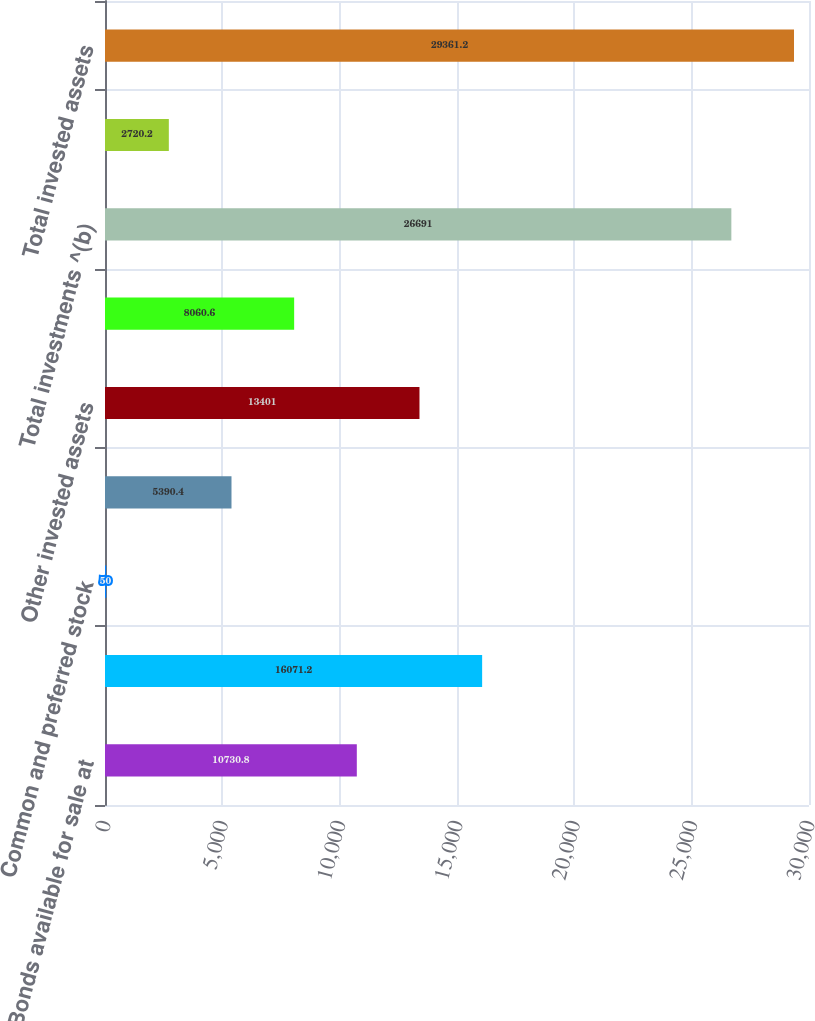Convert chart to OTSL. <chart><loc_0><loc_0><loc_500><loc_500><bar_chart><fcel>Bonds available for sale at<fcel>Other bond securities at fair<fcel>Common and preferred stock<fcel>Mortgage and other loans<fcel>Other invested assets<fcel>Short-term investments<fcel>Total investments ^(b)<fcel>Cash<fcel>Total invested assets<nl><fcel>10730.8<fcel>16071.2<fcel>50<fcel>5390.4<fcel>13401<fcel>8060.6<fcel>26691<fcel>2720.2<fcel>29361.2<nl></chart> 